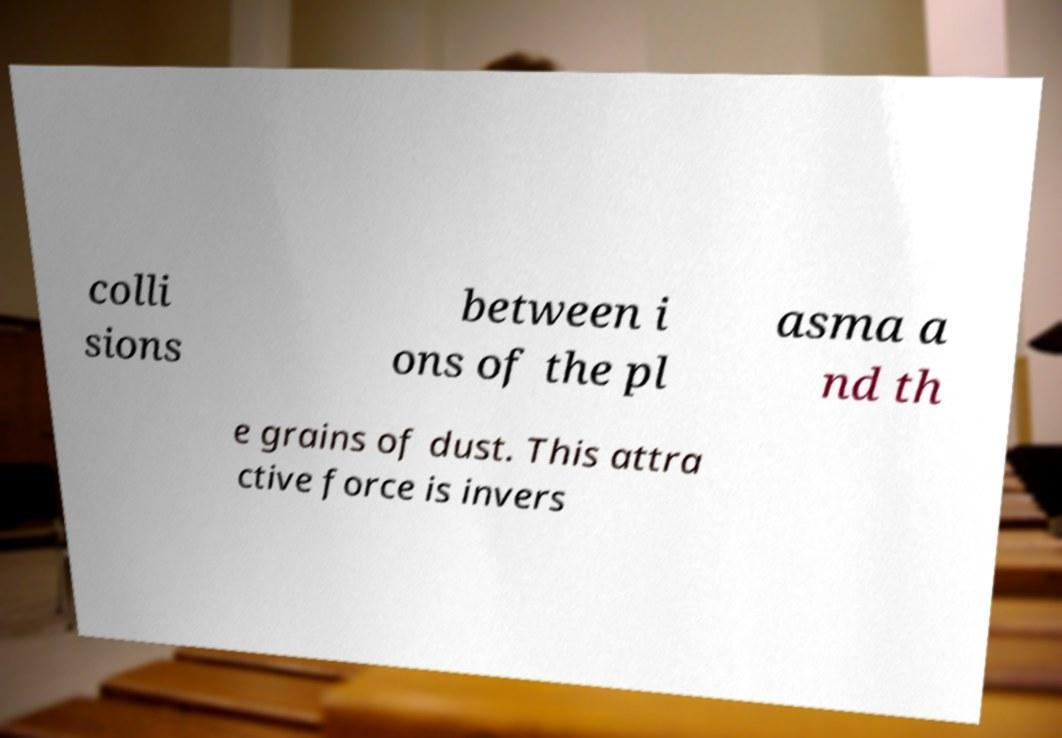Can you accurately transcribe the text from the provided image for me? colli sions between i ons of the pl asma a nd th e grains of dust. This attra ctive force is invers 